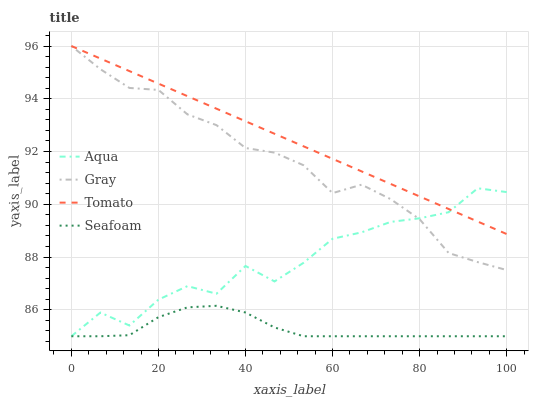Does Seafoam have the minimum area under the curve?
Answer yes or no. Yes. Does Tomato have the maximum area under the curve?
Answer yes or no. Yes. Does Gray have the minimum area under the curve?
Answer yes or no. No. Does Gray have the maximum area under the curve?
Answer yes or no. No. Is Tomato the smoothest?
Answer yes or no. Yes. Is Aqua the roughest?
Answer yes or no. Yes. Is Gray the smoothest?
Answer yes or no. No. Is Gray the roughest?
Answer yes or no. No. Does Aqua have the lowest value?
Answer yes or no. Yes. Does Gray have the lowest value?
Answer yes or no. No. Does Gray have the highest value?
Answer yes or no. Yes. Does Aqua have the highest value?
Answer yes or no. No. Is Seafoam less than Gray?
Answer yes or no. Yes. Is Gray greater than Seafoam?
Answer yes or no. Yes. Does Aqua intersect Tomato?
Answer yes or no. Yes. Is Aqua less than Tomato?
Answer yes or no. No. Is Aqua greater than Tomato?
Answer yes or no. No. Does Seafoam intersect Gray?
Answer yes or no. No. 